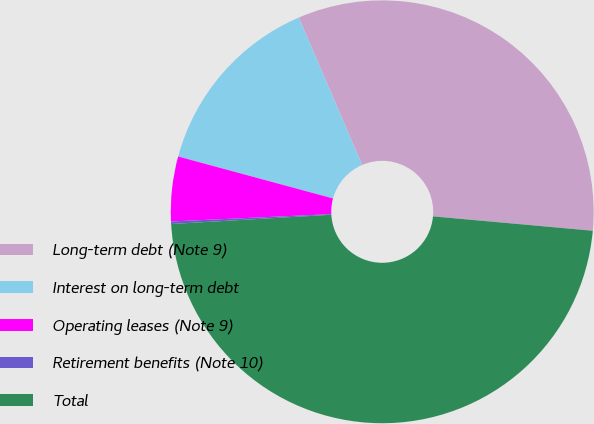<chart> <loc_0><loc_0><loc_500><loc_500><pie_chart><fcel>Long-term debt (Note 9)<fcel>Interest on long-term debt<fcel>Operating leases (Note 9)<fcel>Retirement benefits (Note 10)<fcel>Total<nl><fcel>32.88%<fcel>14.33%<fcel>4.94%<fcel>0.19%<fcel>47.65%<nl></chart> 